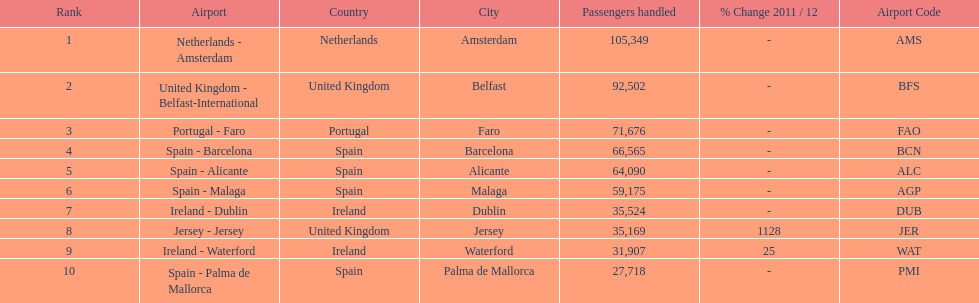Which airport had more passengers handled than the united kingdom? Netherlands - Amsterdam. Would you mind parsing the complete table? {'header': ['Rank', 'Airport', 'Country', 'City', 'Passengers handled', '% Change 2011 / 12', 'Airport Code'], 'rows': [['1', 'Netherlands - Amsterdam', 'Netherlands', 'Amsterdam', '105,349', '-', 'AMS'], ['2', 'United Kingdom - Belfast-International', 'United Kingdom', 'Belfast', '92,502', '-', 'BFS'], ['3', 'Portugal - Faro', 'Portugal', 'Faro', '71,676', '-', 'FAO'], ['4', 'Spain - Barcelona', 'Spain', 'Barcelona', '66,565', '-', 'BCN'], ['5', 'Spain - Alicante', 'Spain', 'Alicante', '64,090', '-', 'ALC'], ['6', 'Spain - Malaga', 'Spain', 'Malaga', '59,175', '-', 'AGP'], ['7', 'Ireland - Dublin', 'Ireland', 'Dublin', '35,524', '-', 'DUB'], ['8', 'Jersey - Jersey', 'United Kingdom', 'Jersey', '35,169', '1128', 'JER'], ['9', 'Ireland - Waterford', 'Ireland', 'Waterford', '31,907', '25', 'WAT'], ['10', 'Spain - Palma de Mallorca', 'Spain', 'Palma de Mallorca', '27,718', '-', 'PMI']]} 